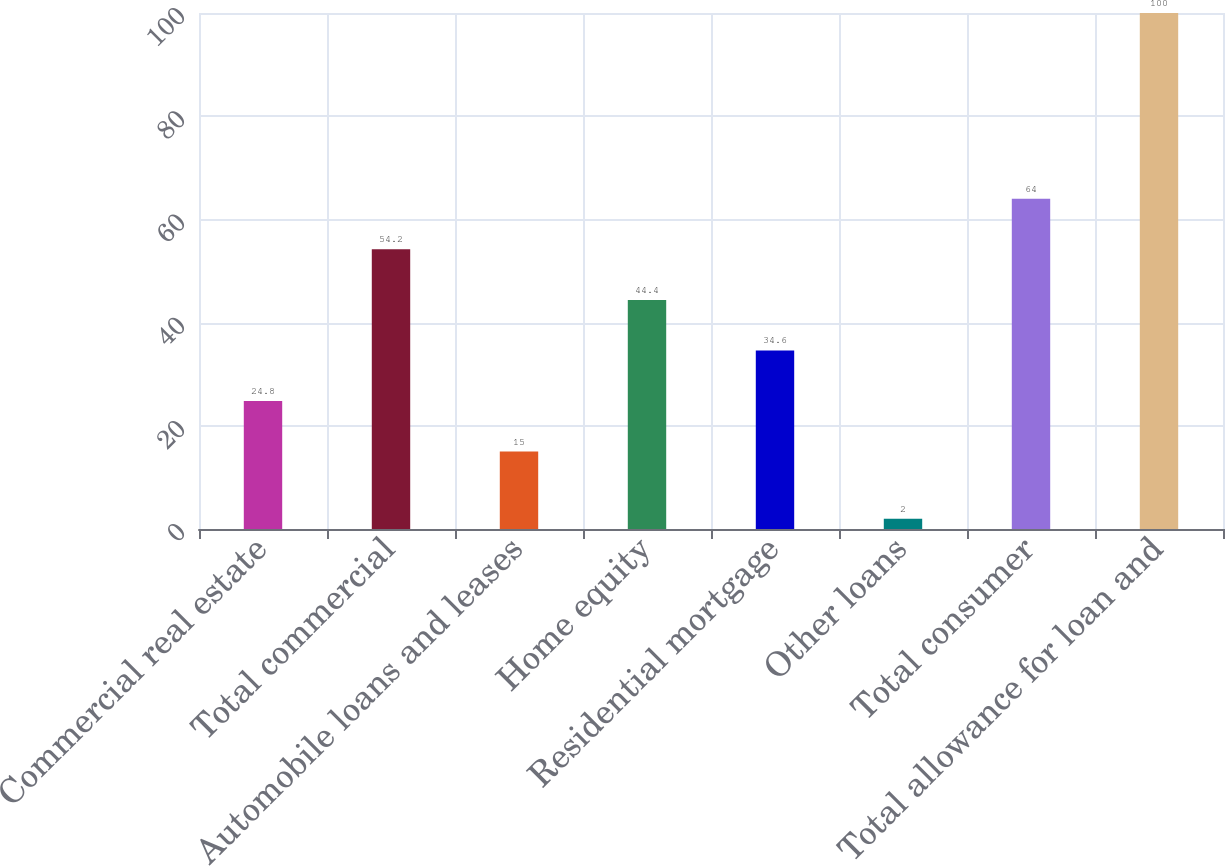<chart> <loc_0><loc_0><loc_500><loc_500><bar_chart><fcel>Commercial real estate<fcel>Total commercial<fcel>Automobile loans and leases<fcel>Home equity<fcel>Residential mortgage<fcel>Other loans<fcel>Total consumer<fcel>Total allowance for loan and<nl><fcel>24.8<fcel>54.2<fcel>15<fcel>44.4<fcel>34.6<fcel>2<fcel>64<fcel>100<nl></chart> 